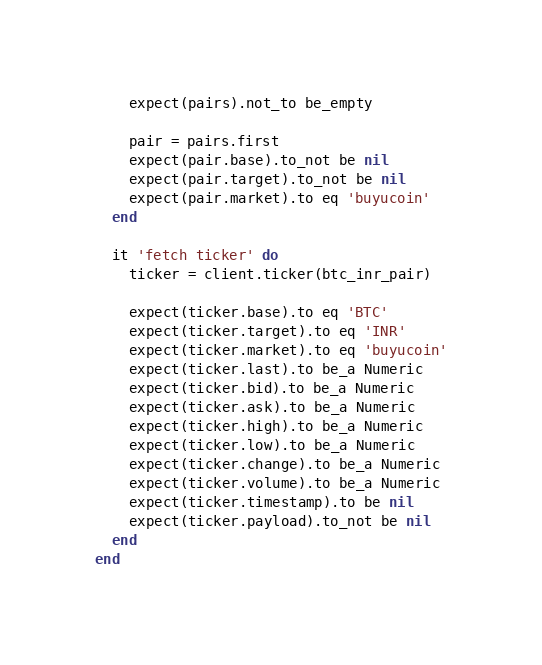Convert code to text. <code><loc_0><loc_0><loc_500><loc_500><_Ruby_>    expect(pairs).not_to be_empty

    pair = pairs.first
    expect(pair.base).to_not be nil
    expect(pair.target).to_not be nil
    expect(pair.market).to eq 'buyucoin'
  end

  it 'fetch ticker' do
    ticker = client.ticker(btc_inr_pair)

    expect(ticker.base).to eq 'BTC'
    expect(ticker.target).to eq 'INR'
    expect(ticker.market).to eq 'buyucoin'
    expect(ticker.last).to be_a Numeric
    expect(ticker.bid).to be_a Numeric
    expect(ticker.ask).to be_a Numeric
    expect(ticker.high).to be_a Numeric
    expect(ticker.low).to be_a Numeric
    expect(ticker.change).to be_a Numeric
    expect(ticker.volume).to be_a Numeric
    expect(ticker.timestamp).to be nil
    expect(ticker.payload).to_not be nil
  end
end
</code> 